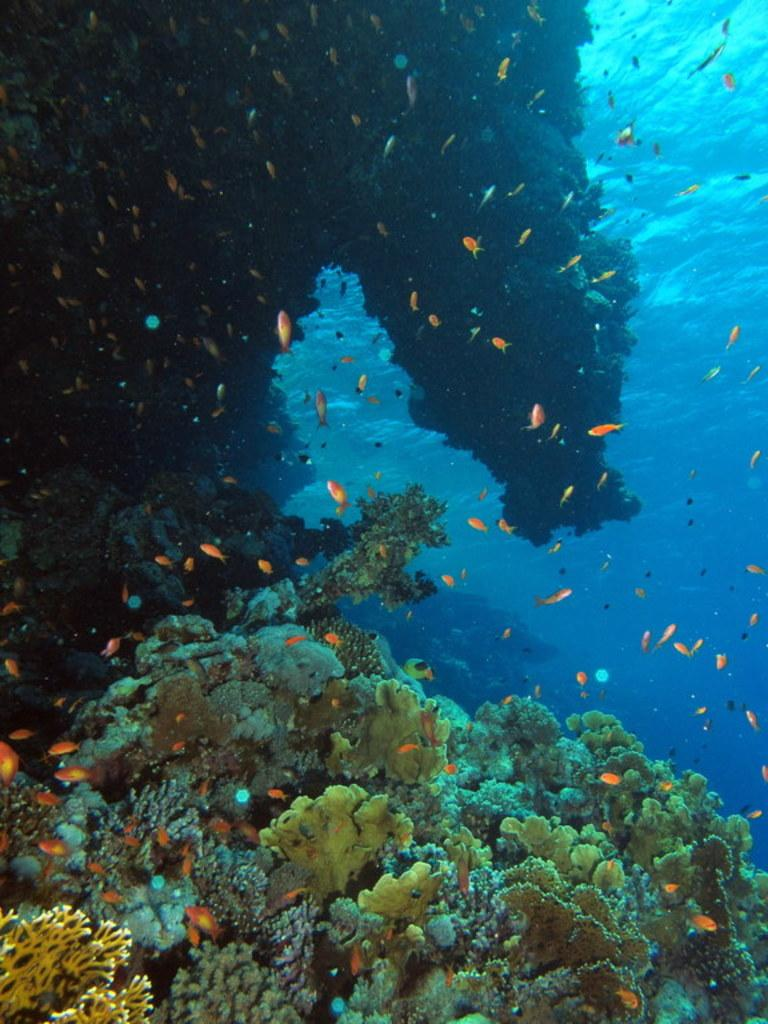What type of environment is shown in the image? The image depicts an underground water environment. What can be found growing in this environment? There are corals in the image. What is the primary substance visible in the image? There is water visible in the image. What type of marine life can be seen in the image? There are fishes in the image. What type of prose can be seen written on the corals in the image? There is no prose visible on the corals in the image; they are natural underwater structures. 